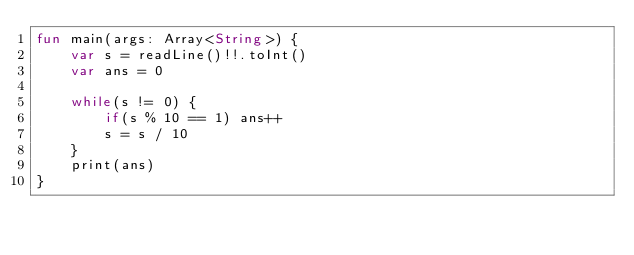Convert code to text. <code><loc_0><loc_0><loc_500><loc_500><_Kotlin_>fun main(args: Array<String>) {
    var s = readLine()!!.toInt()
    var ans = 0

    while(s != 0) {
        if(s % 10 == 1) ans++
        s = s / 10
    }
    print(ans)
}</code> 